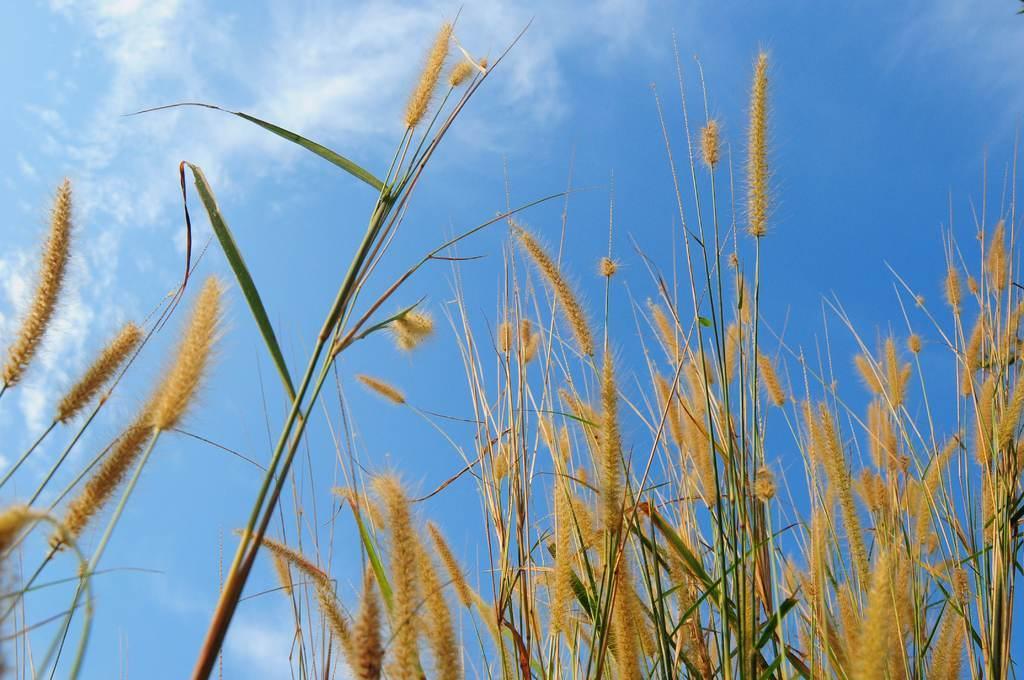How would you summarize this image in a sentence or two? In this picture we can see the brown color wheat plants. Behind there is a blue sky. 